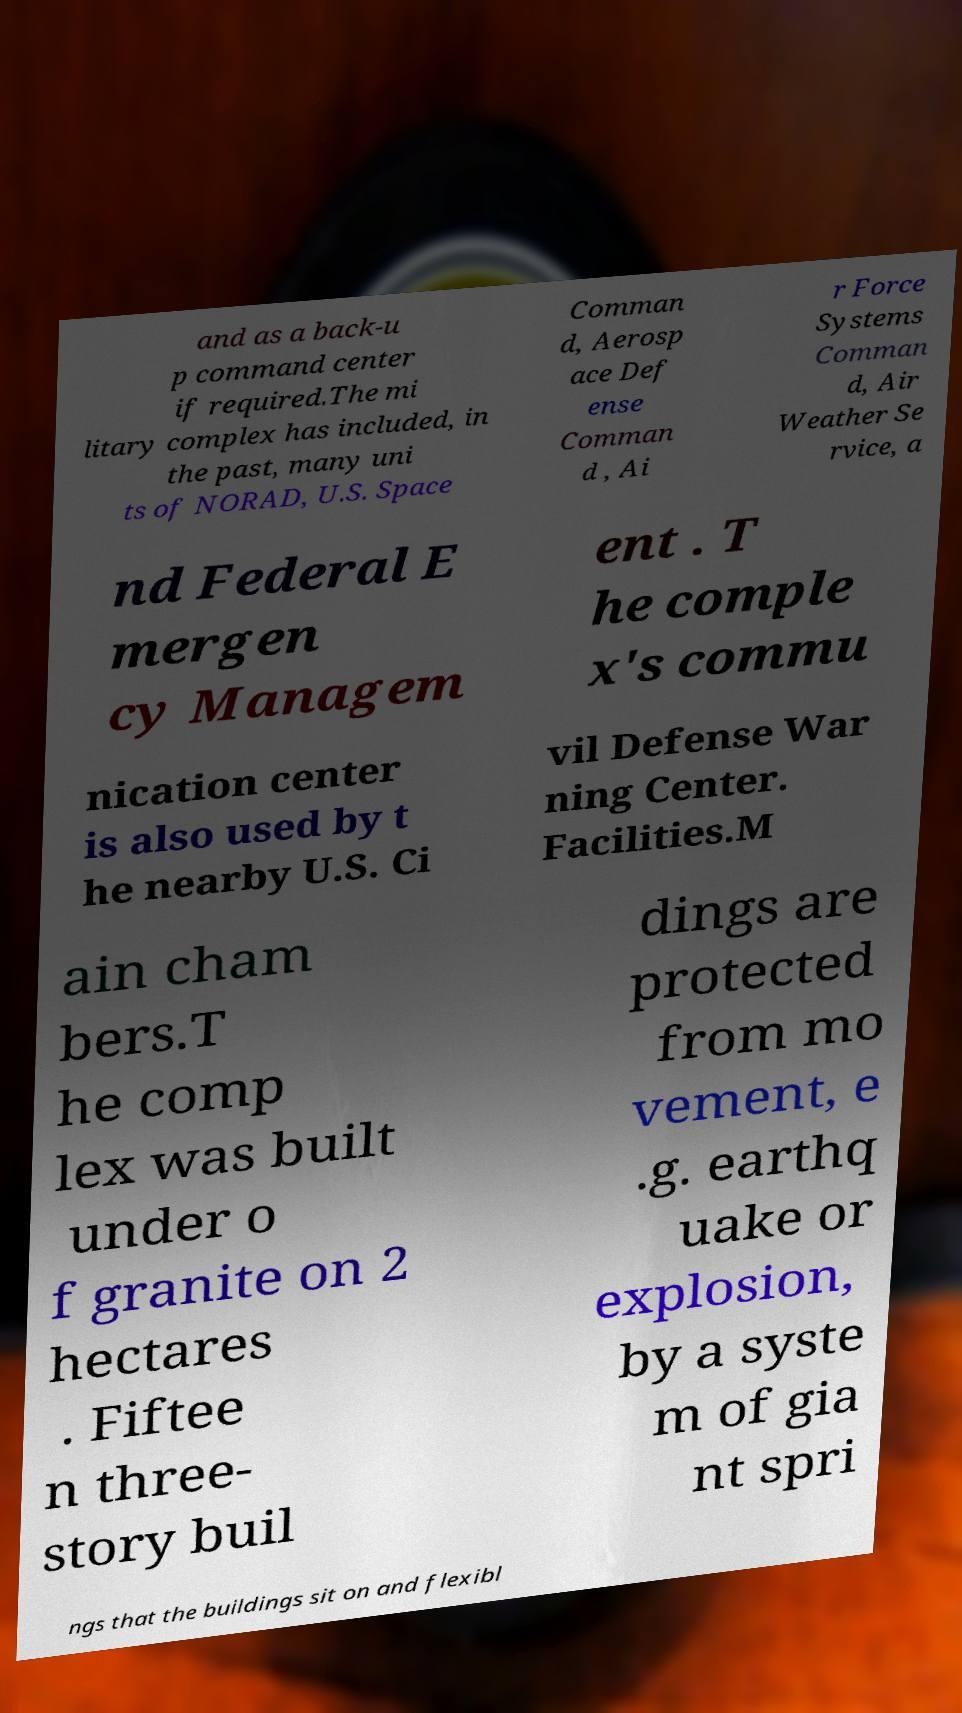Please read and relay the text visible in this image. What does it say? and as a back-u p command center if required.The mi litary complex has included, in the past, many uni ts of NORAD, U.S. Space Comman d, Aerosp ace Def ense Comman d , Ai r Force Systems Comman d, Air Weather Se rvice, a nd Federal E mergen cy Managem ent . T he comple x's commu nication center is also used by t he nearby U.S. Ci vil Defense War ning Center. Facilities.M ain cham bers.T he comp lex was built under o f granite on 2 hectares . Fiftee n three- story buil dings are protected from mo vement, e .g. earthq uake or explosion, by a syste m of gia nt spri ngs that the buildings sit on and flexibl 